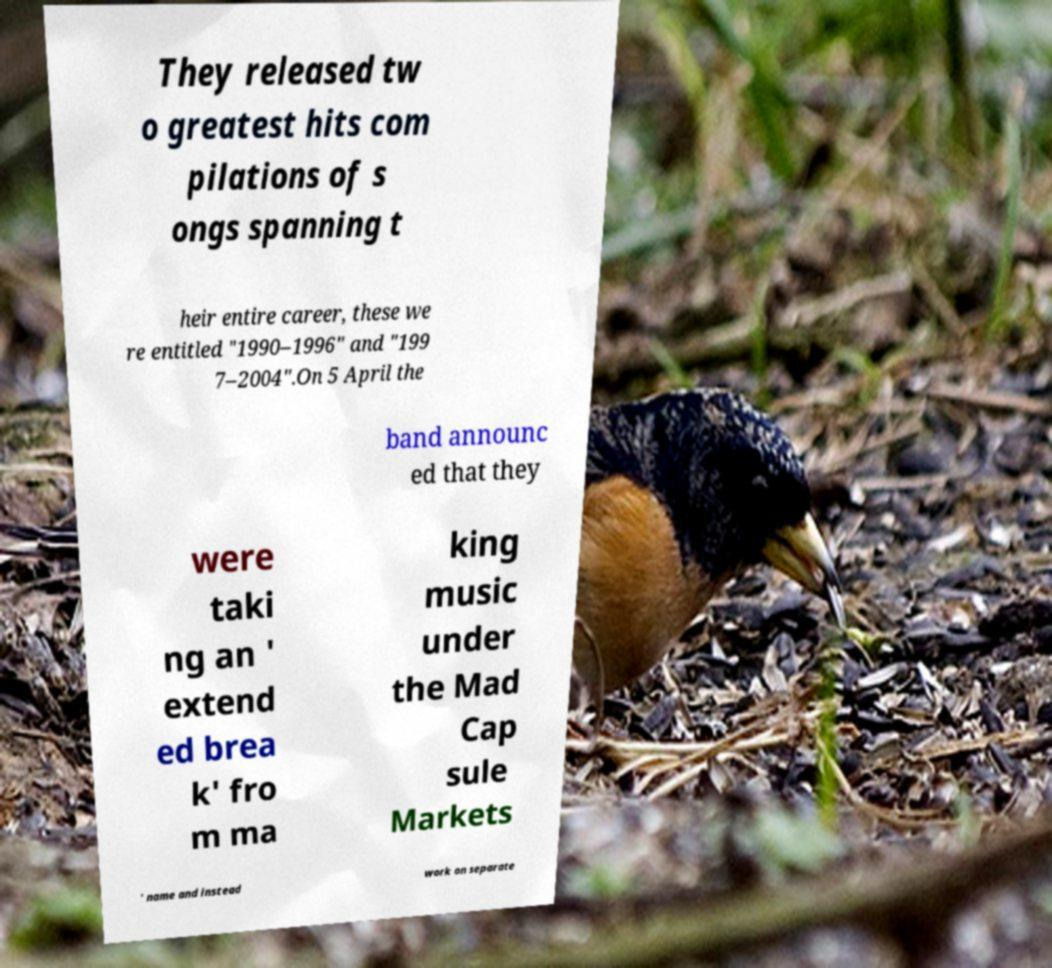For documentation purposes, I need the text within this image transcribed. Could you provide that? They released tw o greatest hits com pilations of s ongs spanning t heir entire career, these we re entitled "1990–1996" and "199 7–2004".On 5 April the band announc ed that they were taki ng an ' extend ed brea k' fro m ma king music under the Mad Cap sule Markets ' name and instead work on separate 